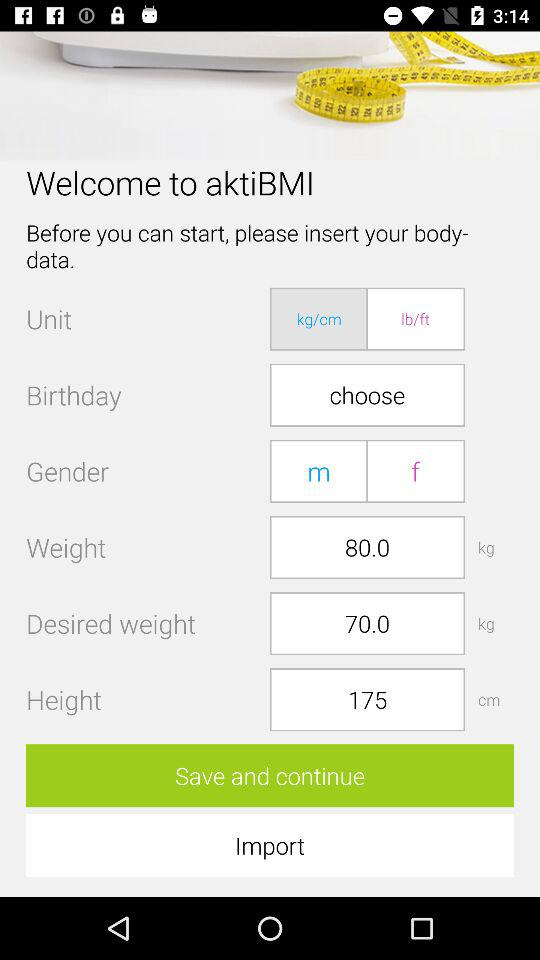What are the gender options? The gender options are "m" and "f". 